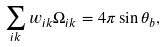<formula> <loc_0><loc_0><loc_500><loc_500>\sum _ { i k } w _ { i k } \Omega _ { i k } = 4 \pi \sin \theta _ { b } ,</formula> 